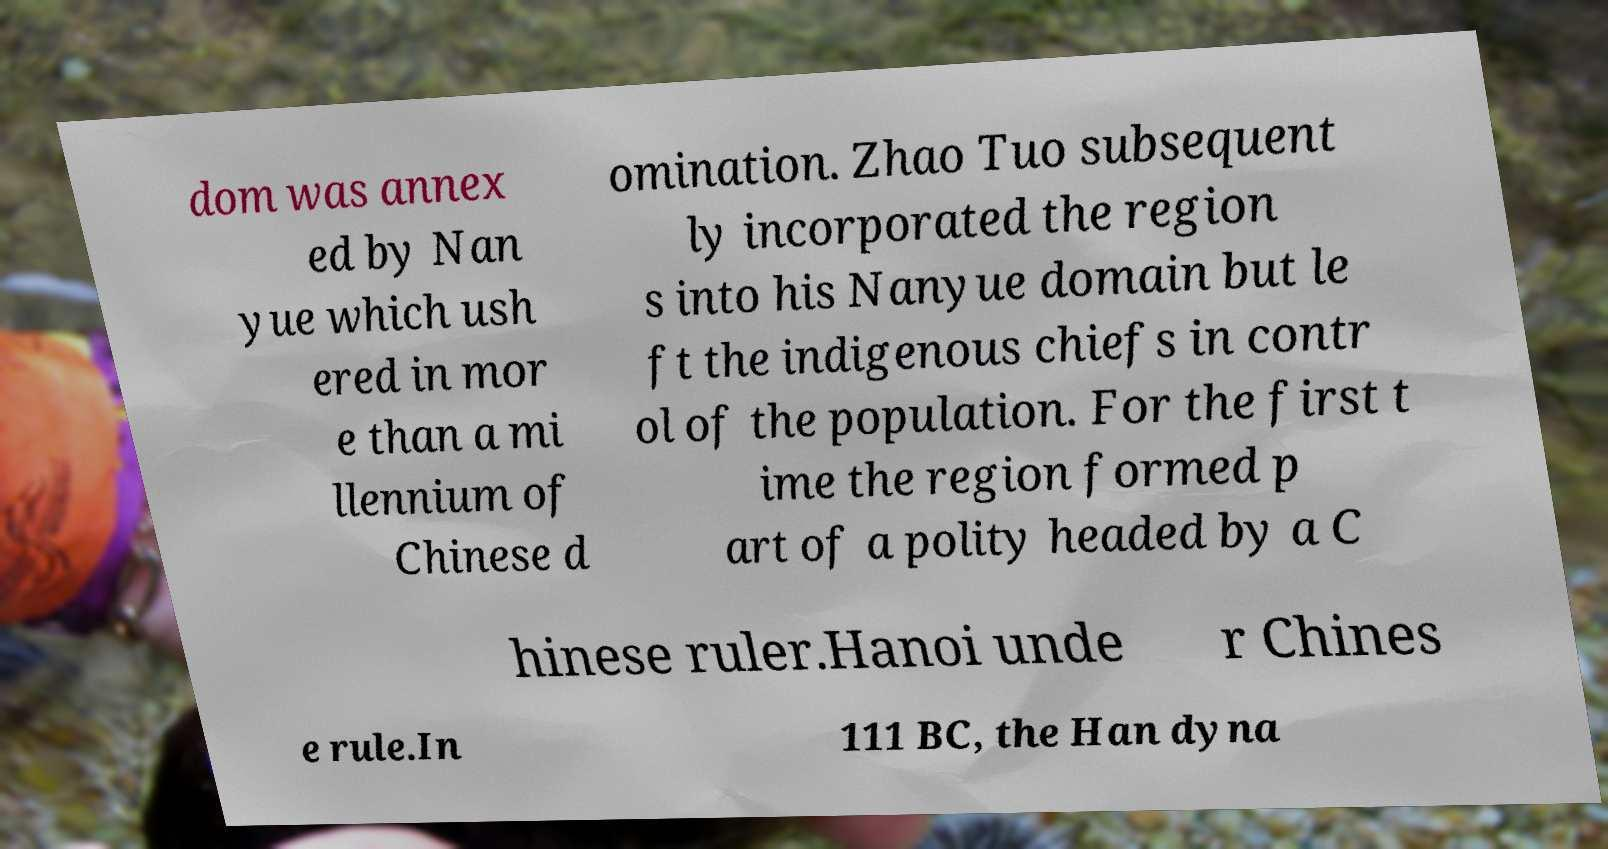For documentation purposes, I need the text within this image transcribed. Could you provide that? dom was annex ed by Nan yue which ush ered in mor e than a mi llennium of Chinese d omination. Zhao Tuo subsequent ly incorporated the region s into his Nanyue domain but le ft the indigenous chiefs in contr ol of the population. For the first t ime the region formed p art of a polity headed by a C hinese ruler.Hanoi unde r Chines e rule.In 111 BC, the Han dyna 